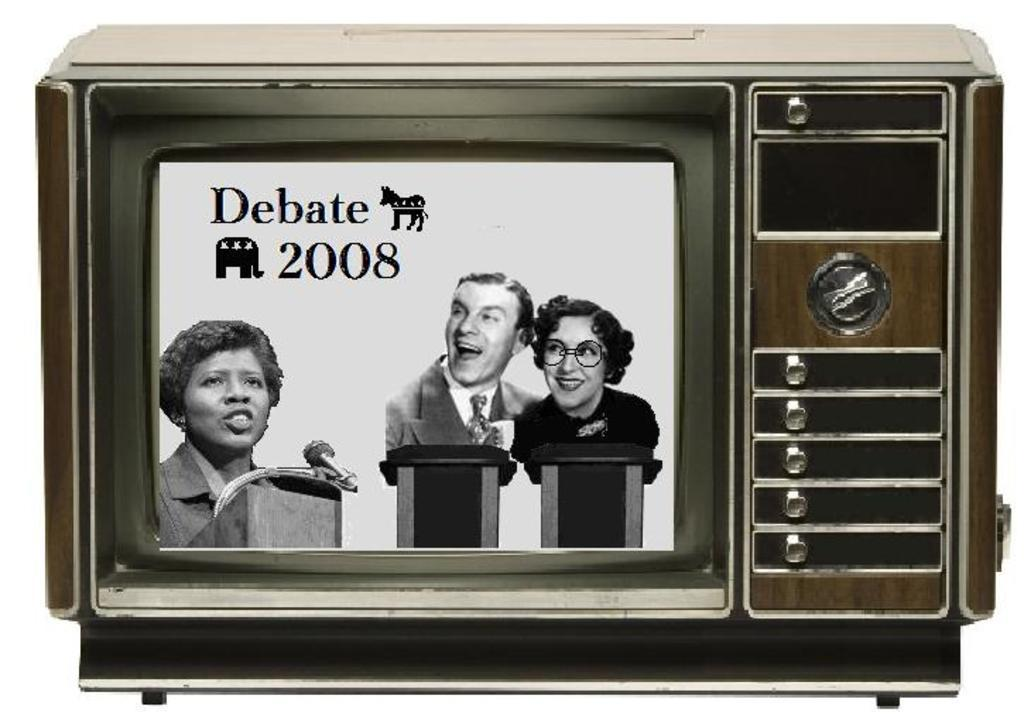<image>
Summarize the visual content of the image. An old television set shows the debate of 2008. 